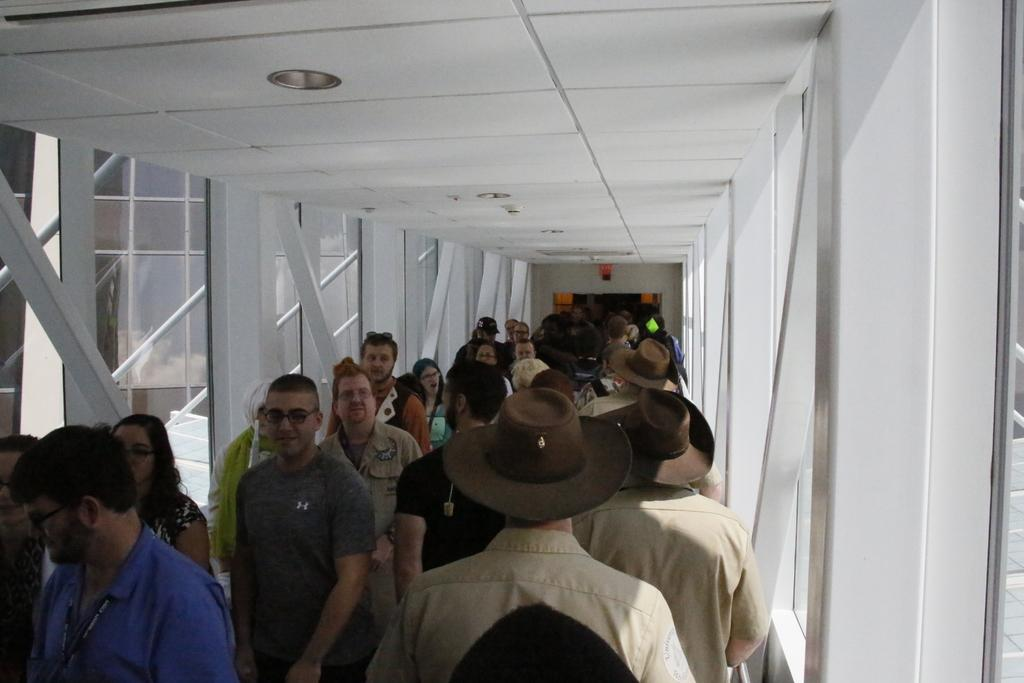What are the people in the image doing? There is a group of persons walking in the image. What object can be seen in the image that is typically used for holding liquids? There is a glass in the image. What is the source of light in the image? There is a light above in the image. What structure is visible in the image that provides shelter? There is a roof in the image. What type of needle is being used by the person in the image? There is no needle present in the image. What material is the leather bag being carried by the person in the image? There is no leather bag or any bag visible in the image. 